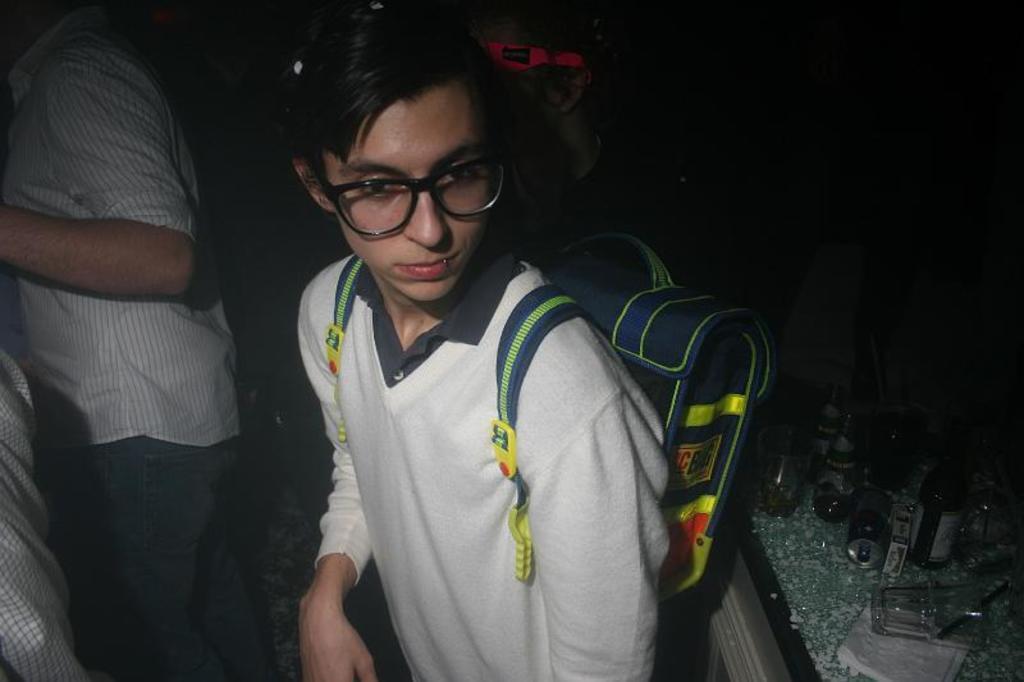Please provide a concise description of this image. In this picture we can see a person with the backpack. Behind the person there is a group of people standing. On the right side of the people, it looks like a table and on the table there are glasses, bottles and tissue papers. 